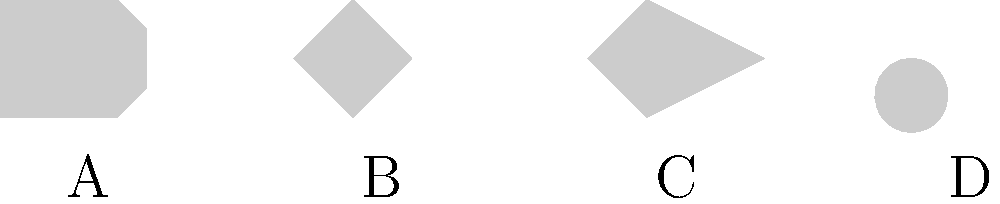As an English teacher with a passion for science fiction, you're developing a lesson plan that incorporates visual analysis of spacecraft designs. In the image above, which spacecraft shape would be most likely to appear in a classic 1950s science fiction novel, aligning with the era's popular depiction of UFOs? To answer this question, let's analyze each spacecraft design in the context of 1950s science fiction:

1. Design A: This is a classic rocket-ship design, more common in early space exploration narratives.

2. Design B: A diamond-shaped craft, which is less common in 1950s sci-fi.

3. Design C: An arrow-shaped design, typically associated with more modern or futuristic depictions.

4. Design D: This is a saucer-shaped craft, which is the quintessential UFO design from 1950s science fiction.

The 1950s was the golden age of UFO sightings and alien invasion stories. During this era, the most popular and widely reported shape for UFOs was the "flying saucer" or disc-shaped object. This image became deeply ingrained in popular culture through movies, pulp fiction, and reported sightings.

The saucer shape (Design D) perfectly embodies the mystique and otherworldliness that captivated audiences in 1950s science fiction. It's smooth, aerodynamic form suggested advanced technology beyond human understanding, which was a common theme in the genre during that time.

Therefore, the spacecraft shape most likely to appear in a classic 1950s science fiction novel would be Design D, the saucer-shaped craft.
Answer: D 